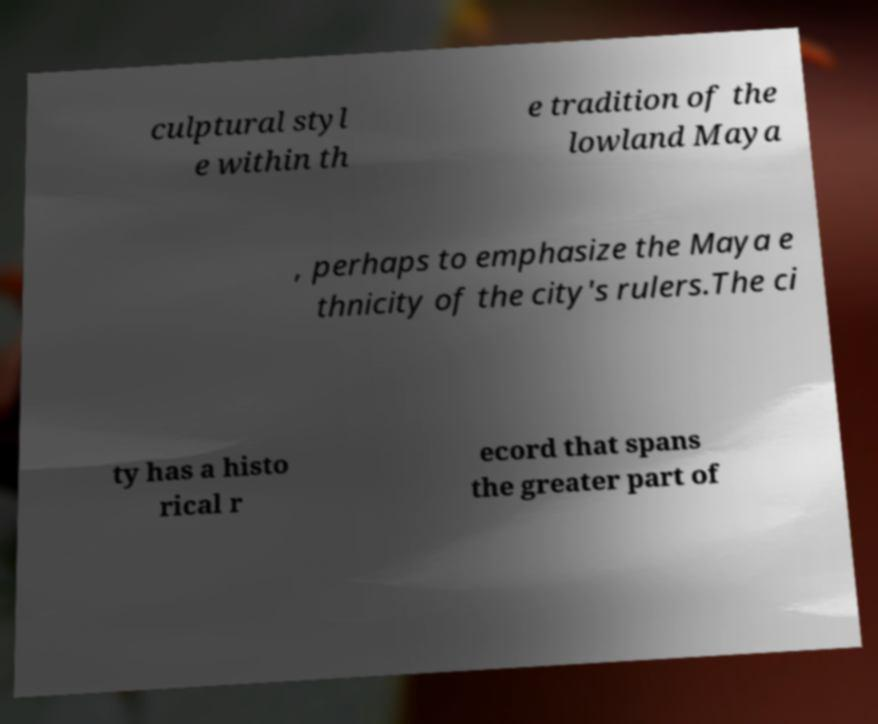Could you extract and type out the text from this image? culptural styl e within th e tradition of the lowland Maya , perhaps to emphasize the Maya e thnicity of the city's rulers.The ci ty has a histo rical r ecord that spans the greater part of 